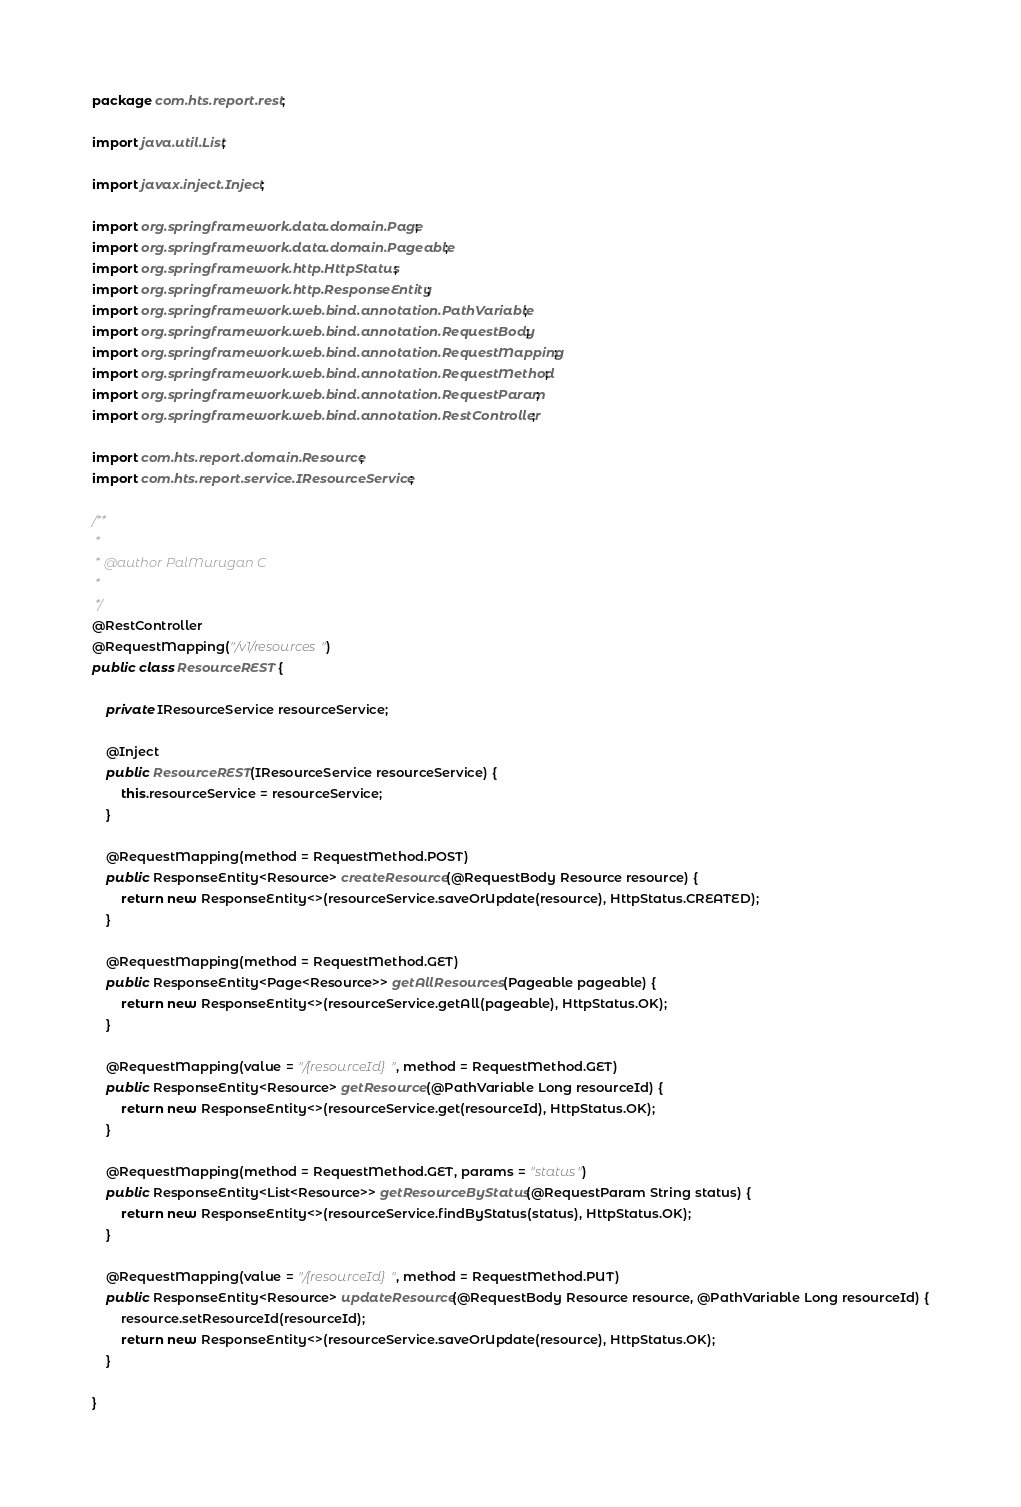<code> <loc_0><loc_0><loc_500><loc_500><_Java_>package com.hts.report.rest;

import java.util.List;

import javax.inject.Inject;

import org.springframework.data.domain.Page;
import org.springframework.data.domain.Pageable;
import org.springframework.http.HttpStatus;
import org.springframework.http.ResponseEntity;
import org.springframework.web.bind.annotation.PathVariable;
import org.springframework.web.bind.annotation.RequestBody;
import org.springframework.web.bind.annotation.RequestMapping;
import org.springframework.web.bind.annotation.RequestMethod;
import org.springframework.web.bind.annotation.RequestParam;
import org.springframework.web.bind.annotation.RestController;

import com.hts.report.domain.Resource;
import com.hts.report.service.IResourceService;

/**
 * 
 * @author PalMurugan C
 *
 */
@RestController
@RequestMapping("/v1/resources")
public class ResourceREST {

	private IResourceService resourceService;

	@Inject
	public ResourceREST(IResourceService resourceService) {
		this.resourceService = resourceService;
	}

	@RequestMapping(method = RequestMethod.POST)
	public ResponseEntity<Resource> createResource(@RequestBody Resource resource) {
		return new ResponseEntity<>(resourceService.saveOrUpdate(resource), HttpStatus.CREATED);
	}

	@RequestMapping(method = RequestMethod.GET)
	public ResponseEntity<Page<Resource>> getAllResources(Pageable pageable) {
		return new ResponseEntity<>(resourceService.getAll(pageable), HttpStatus.OK);
	}

    @RequestMapping(value = "/{resourceId}", method = RequestMethod.GET)
    public ResponseEntity<Resource> getResource(@PathVariable Long resourceId) {
        return new ResponseEntity<>(resourceService.get(resourceId), HttpStatus.OK);
	}

	@RequestMapping(method = RequestMethod.GET, params = "status")
	public ResponseEntity<List<Resource>> getResourceByStatus(@RequestParam String status) {
		return new ResponseEntity<>(resourceService.findByStatus(status), HttpStatus.OK);
	}

    @RequestMapping(value = "/{resourceId}", method = RequestMethod.PUT)
	public ResponseEntity<Resource> updateResource(@RequestBody Resource resource, @PathVariable Long resourceId) {
		resource.setResourceId(resourceId);
		return new ResponseEntity<>(resourceService.saveOrUpdate(resource), HttpStatus.OK);
	}

}
</code> 